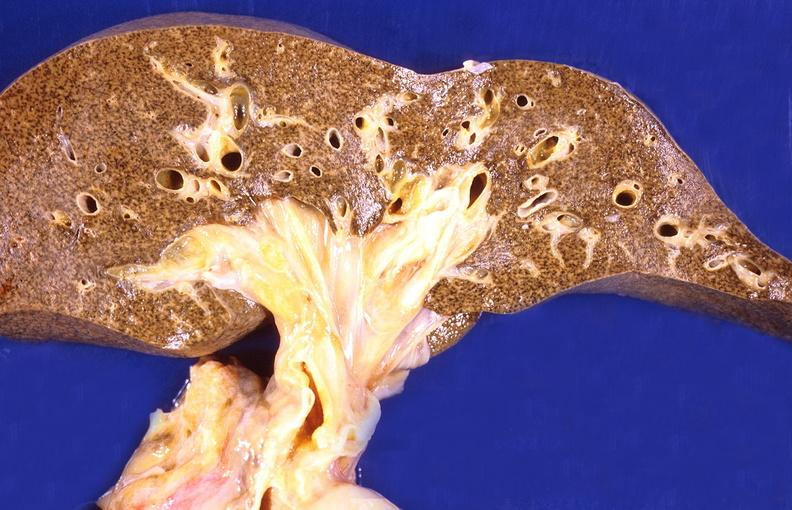what is present?
Answer the question using a single word or phrase. Liver 